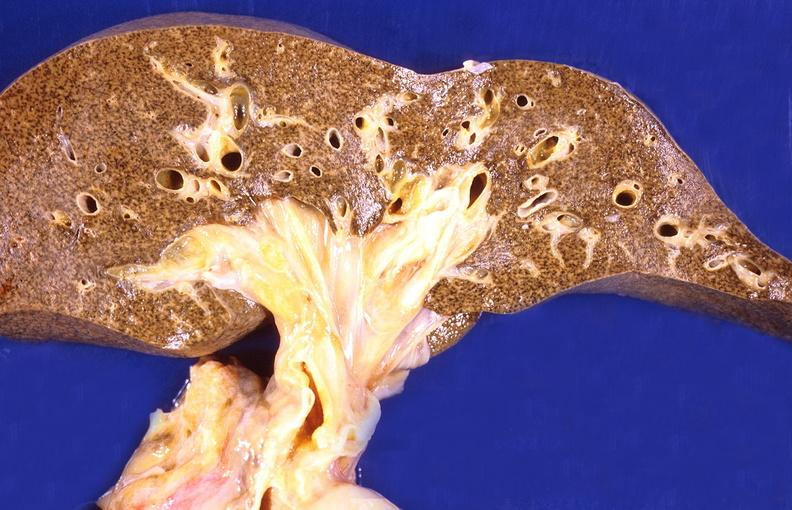what is present?
Answer the question using a single word or phrase. Liver 